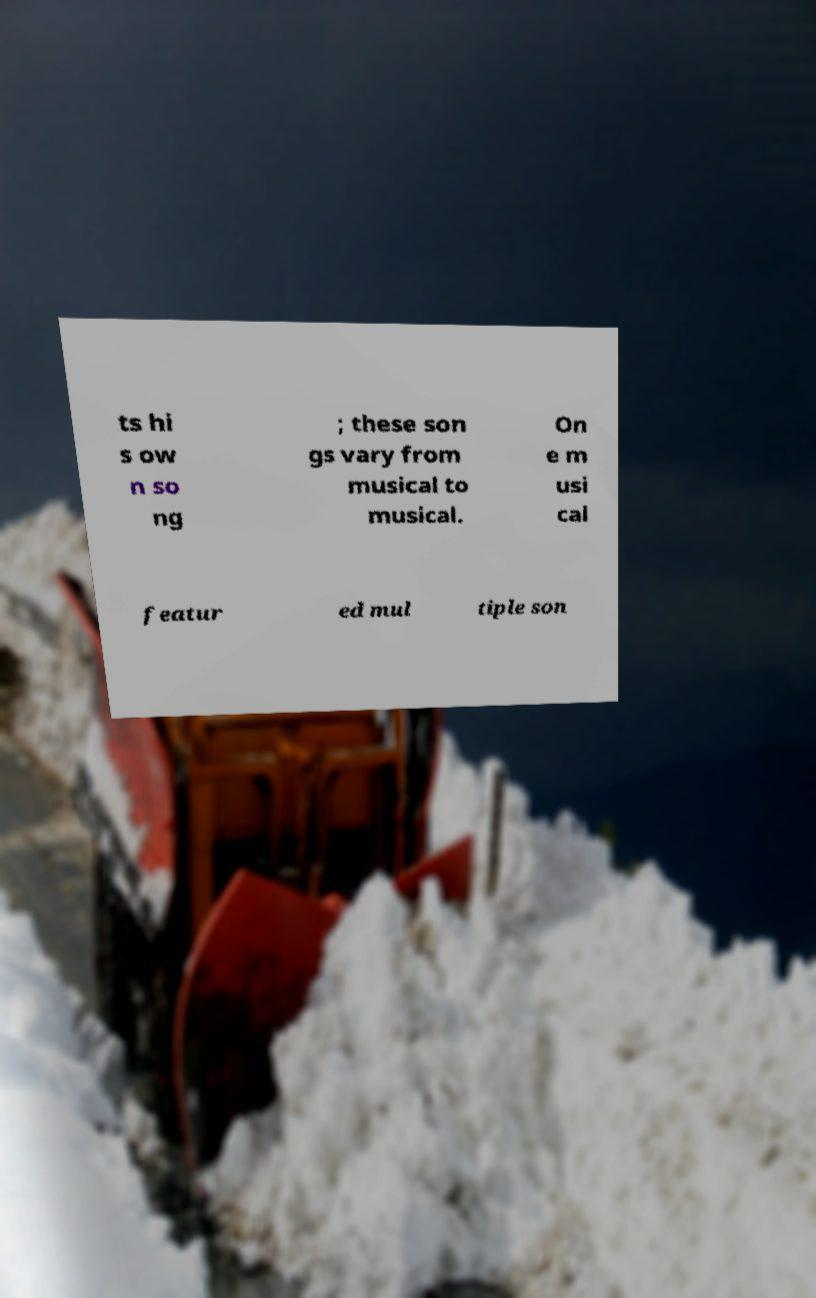Please read and relay the text visible in this image. What does it say? ts hi s ow n so ng ; these son gs vary from musical to musical. On e m usi cal featur ed mul tiple son 